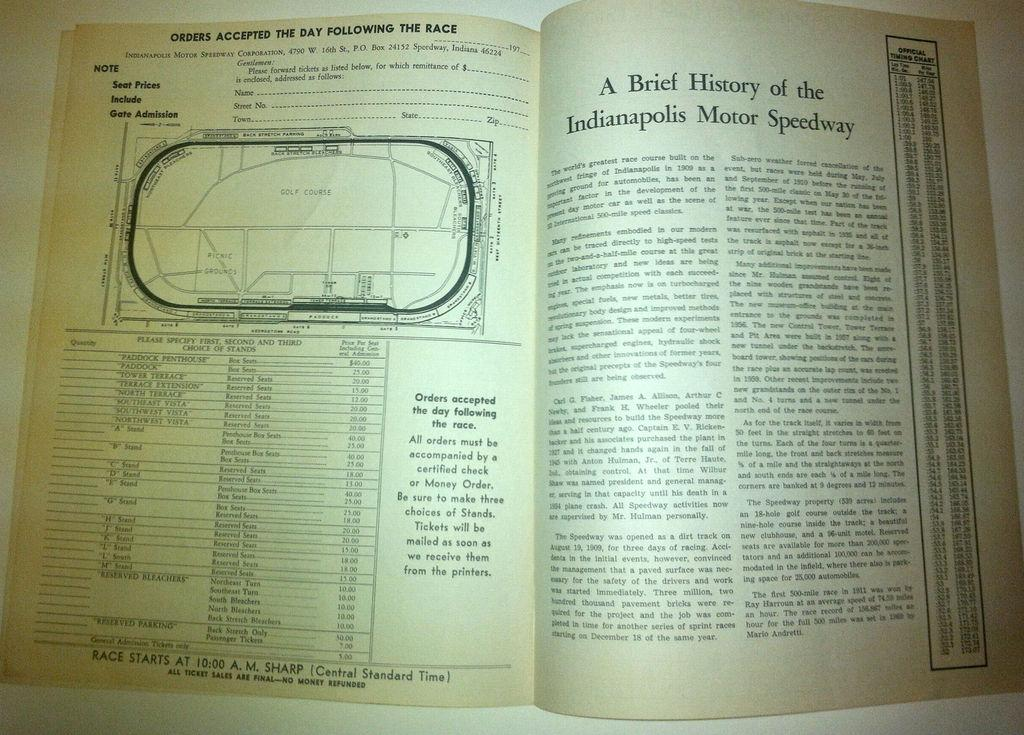<image>
Give a short and clear explanation of the subsequent image. A book opened with the page on the right talking about the history of the Indianapolis Motor Speedway. 